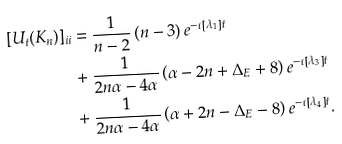Convert formula to latex. <formula><loc_0><loc_0><loc_500><loc_500>[ U _ { t } ( K _ { n } ) ] _ { i i } & = \frac { 1 } { n - 2 } \left ( n - 3 \right ) e ^ { - \iota \left [ \lambda _ { 1 } \right ] t } \\ & + \frac { 1 } { 2 n \alpha - 4 \alpha } \left ( \alpha - 2 n + \Delta _ { E } + 8 \right ) e ^ { - \iota \left [ \lambda _ { 3 } \right ] t } \\ & + \frac { 1 } { 2 n \alpha - 4 \alpha } \left ( \alpha + 2 n - \Delta _ { E } - 8 \right ) e ^ { - \iota \left [ \lambda _ { 4 } \right ] t } .</formula> 